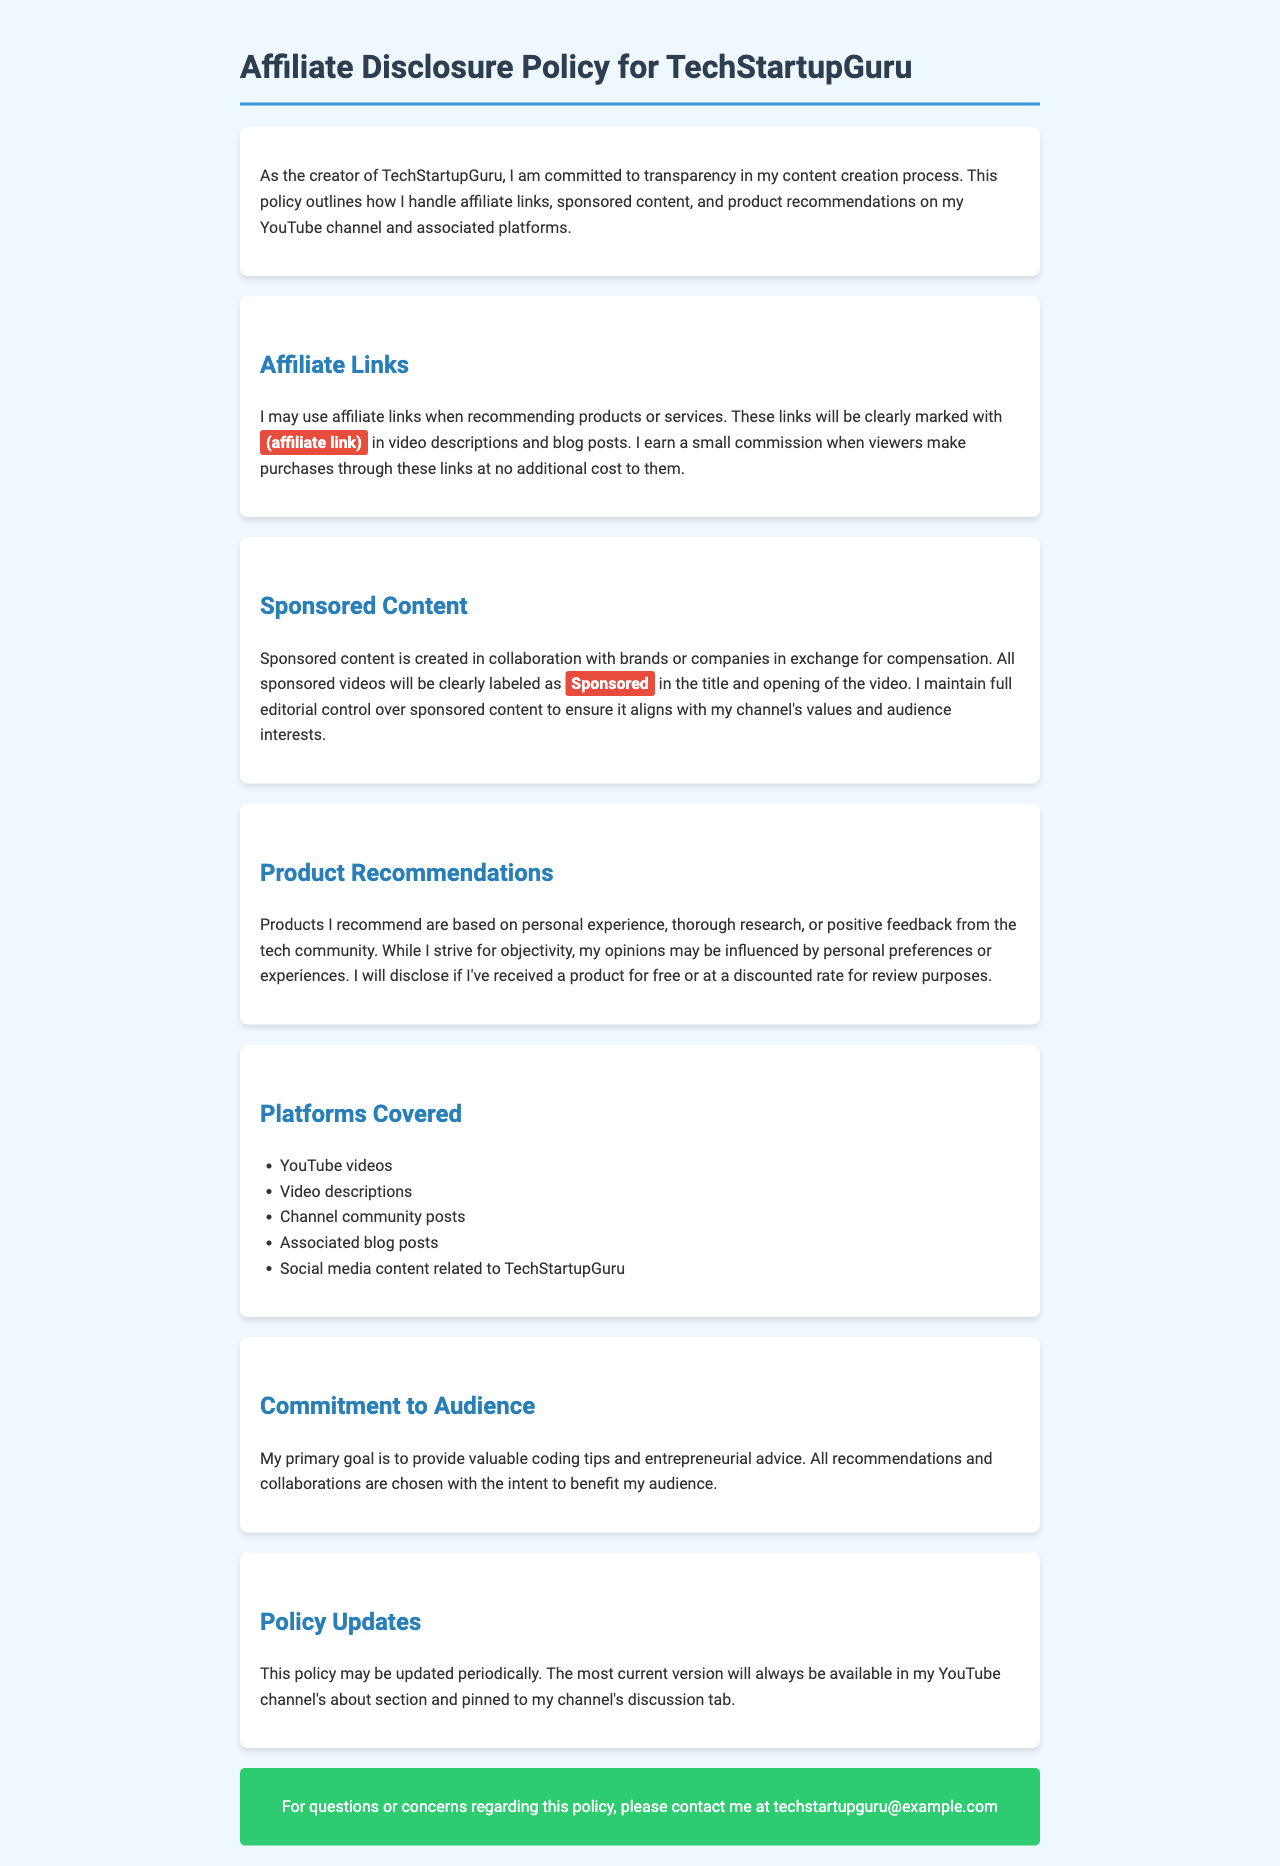What does the affiliate link signify? The document states that affiliate links are clearly marked with (affiliate link).
Answer: (affiliate link) How is sponsored content indicated in the videos? Sponsored videos will be clearly labeled as Sponsored in the title and opening of the video.
Answer: Sponsored What influences product recommendations? Opinions on product recommendations may be influenced by personal preferences or experiences.
Answer: Personal preferences Which platforms are covered by the policy? The policy covers multiple platforms, specifically mentioned as YouTube videos, video descriptions, and others.
Answer: YouTube videos What is my primary goal according to the document? The document mentions the primary goal is to provide valuable coding tips and entrepreneurial advice.
Answer: Valuable coding tips and entrepreneurial advice How often may the policy be updated? The document notes that this policy may be updated periodically.
Answer: Periodically What should you do if you have questions about the policy? For questions or concerns, you are instructed to contact the creator at the provided email address.
Answer: Contact via email Which color is used for the highlighted sections in the document? The highlighted sections are indicated with a background color of e74c3c.
Answer: e74c3c What does the audience benefit from according to the commitment? The commitment states all recommendations and collaborations are chosen to benefit the audience.
Answer: Benefit the audience 